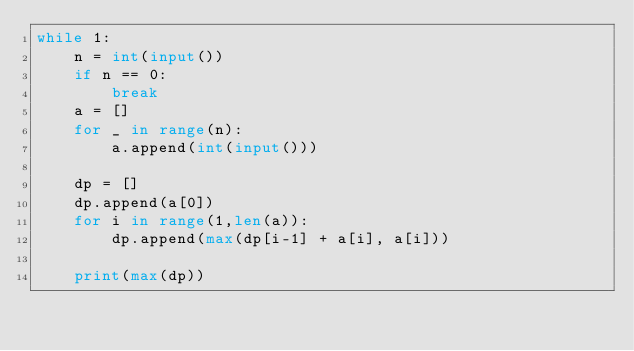Convert code to text. <code><loc_0><loc_0><loc_500><loc_500><_Python_>while 1:
    n = int(input())
    if n == 0:
        break
    a = []
    for _ in range(n):
        a.append(int(input()))

    dp = []
    dp.append(a[0])
    for i in range(1,len(a)):
        dp.append(max(dp[i-1] + a[i], a[i]))

    print(max(dp))</code> 